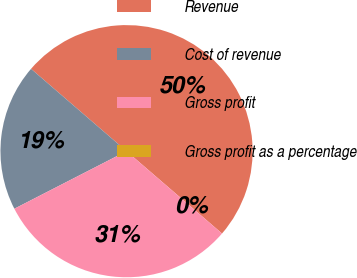Convert chart to OTSL. <chart><loc_0><loc_0><loc_500><loc_500><pie_chart><fcel>Revenue<fcel>Cost of revenue<fcel>Gross profit<fcel>Gross profit as a percentage<nl><fcel>50.0%<fcel>18.87%<fcel>31.13%<fcel>0.0%<nl></chart> 